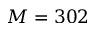<formula> <loc_0><loc_0><loc_500><loc_500>M = 3 0 2</formula> 